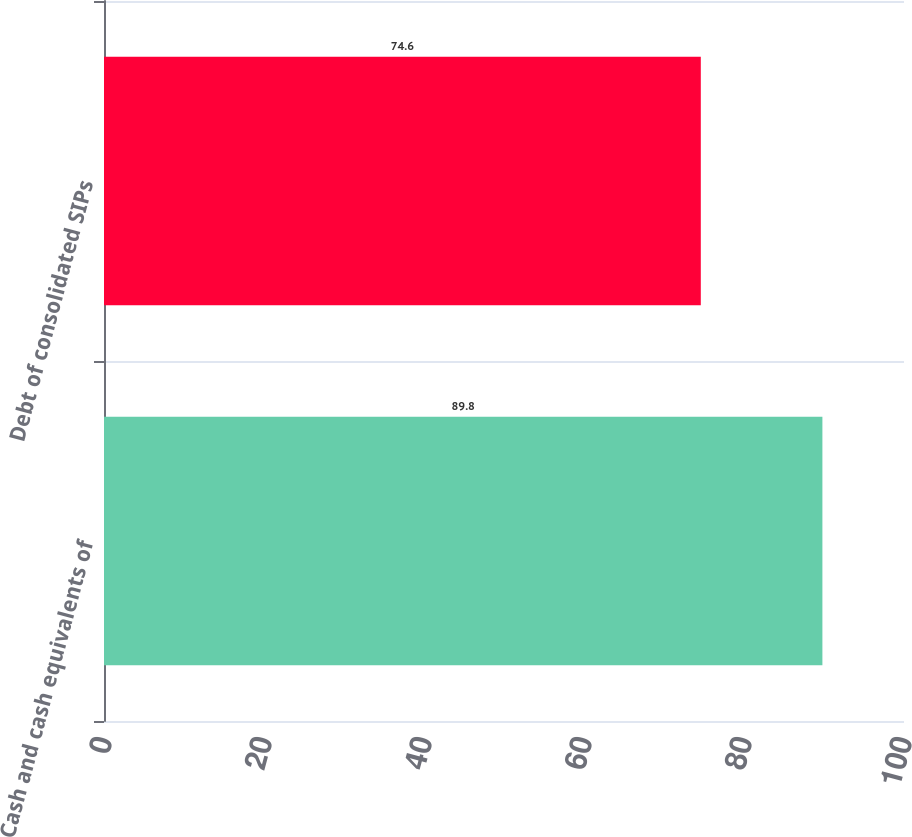Convert chart to OTSL. <chart><loc_0><loc_0><loc_500><loc_500><bar_chart><fcel>Cash and cash equivalents of<fcel>Debt of consolidated SIPs<nl><fcel>89.8<fcel>74.6<nl></chart> 